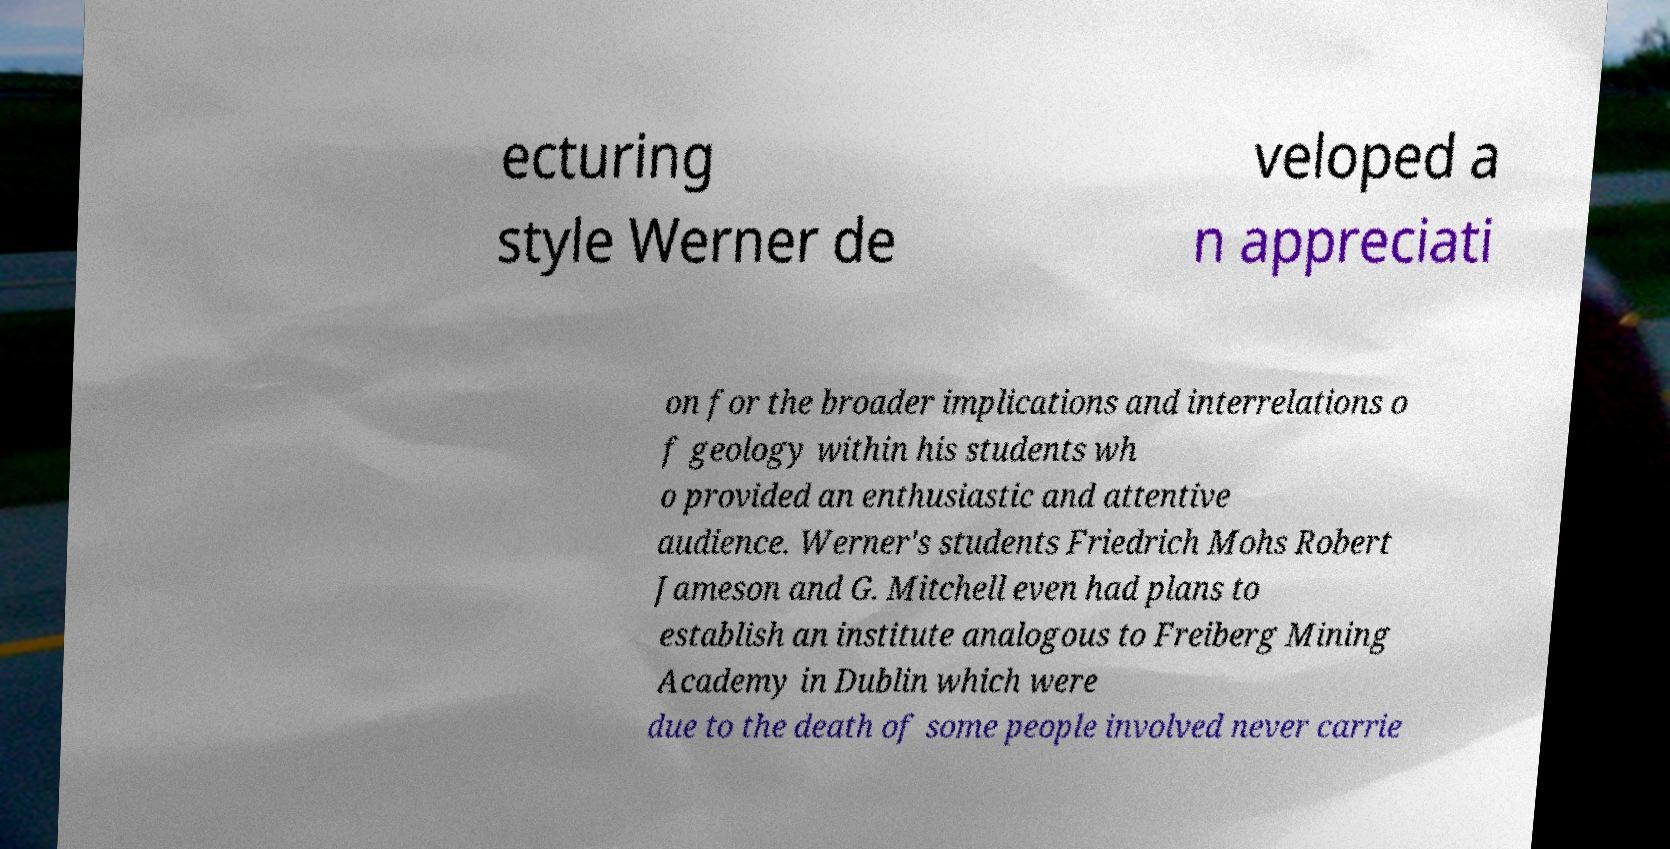There's text embedded in this image that I need extracted. Can you transcribe it verbatim? ecturing style Werner de veloped a n appreciati on for the broader implications and interrelations o f geology within his students wh o provided an enthusiastic and attentive audience. Werner's students Friedrich Mohs Robert Jameson and G. Mitchell even had plans to establish an institute analogous to Freiberg Mining Academy in Dublin which were due to the death of some people involved never carrie 